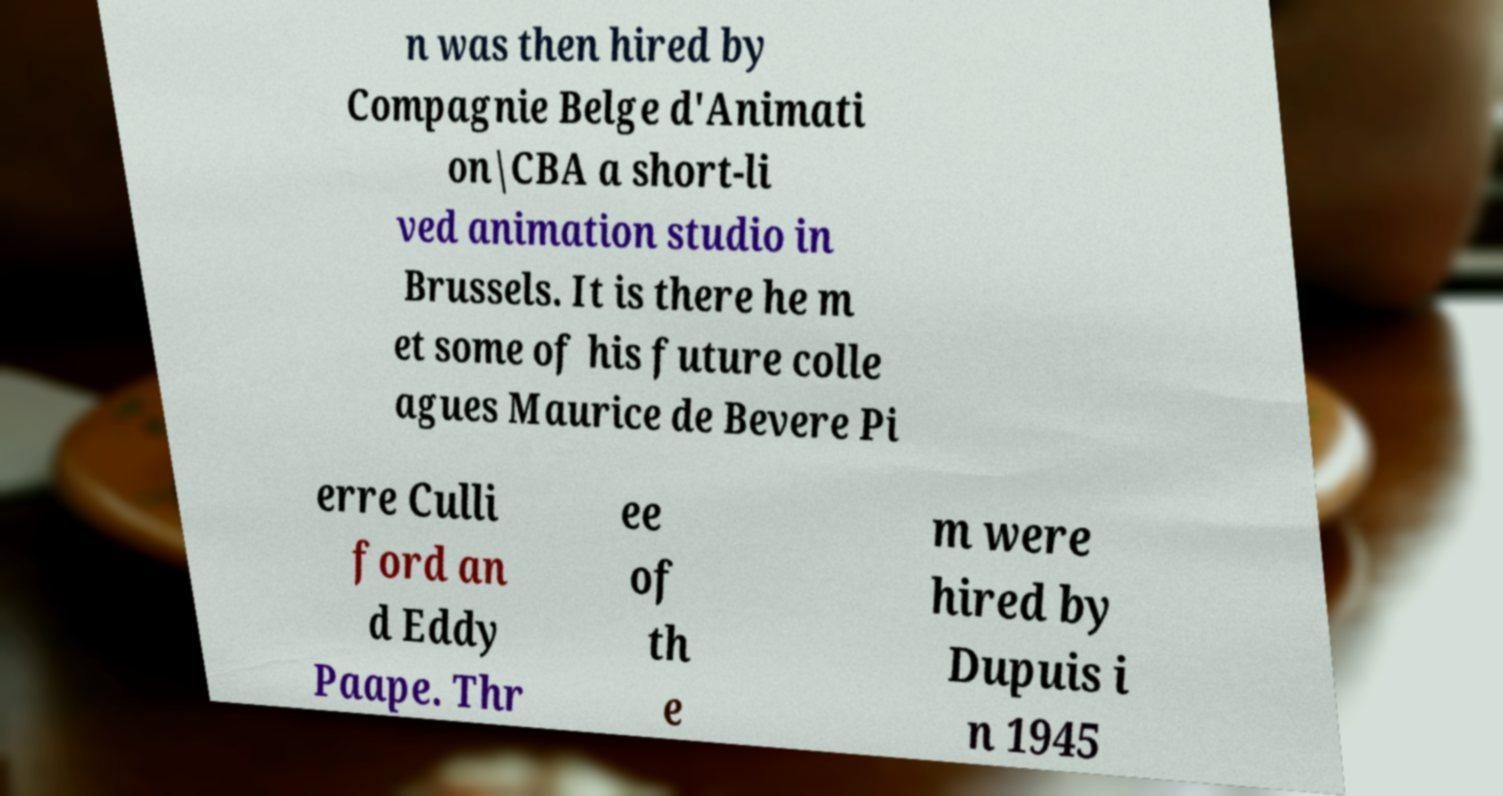I need the written content from this picture converted into text. Can you do that? n was then hired by Compagnie Belge d'Animati on|CBA a short-li ved animation studio in Brussels. It is there he m et some of his future colle agues Maurice de Bevere Pi erre Culli ford an d Eddy Paape. Thr ee of th e m were hired by Dupuis i n 1945 